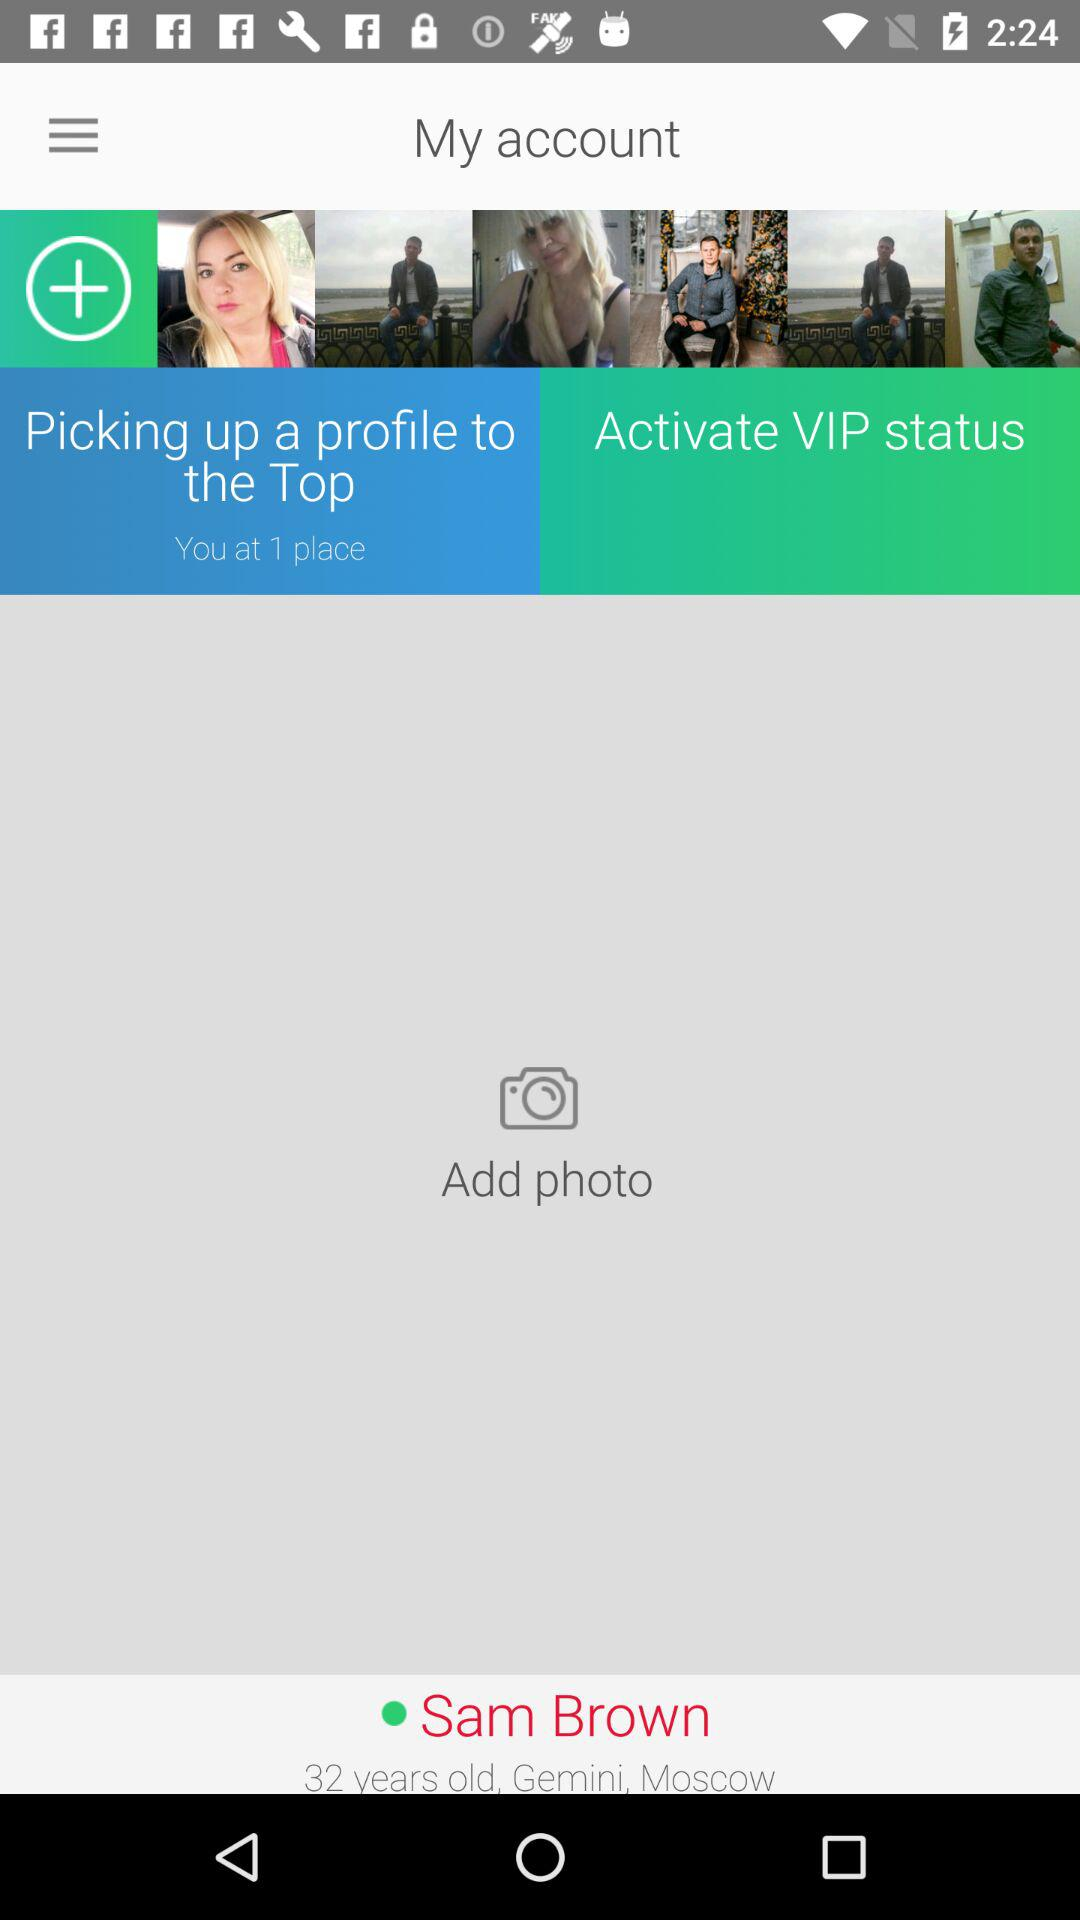How many photos are there in Sam Brown's profile?
Answer the question using a single word or phrase. 6 